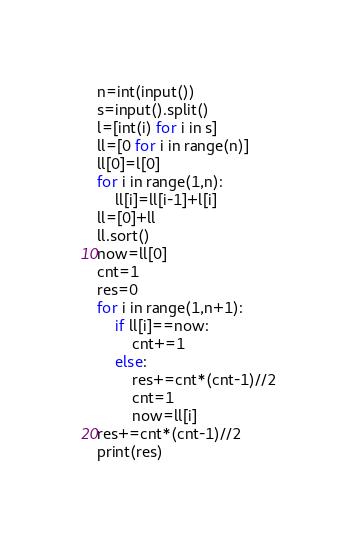Convert code to text. <code><loc_0><loc_0><loc_500><loc_500><_Python_>n=int(input())
s=input().split()
l=[int(i) for i in s]
ll=[0 for i in range(n)]
ll[0]=l[0]
for i in range(1,n):
    ll[i]=ll[i-1]+l[i]
ll=[0]+ll
ll.sort()
now=ll[0]
cnt=1
res=0
for i in range(1,n+1):
    if ll[i]==now:
        cnt+=1
    else:
        res+=cnt*(cnt-1)//2
        cnt=1
        now=ll[i]
res+=cnt*(cnt-1)//2
print(res)</code> 